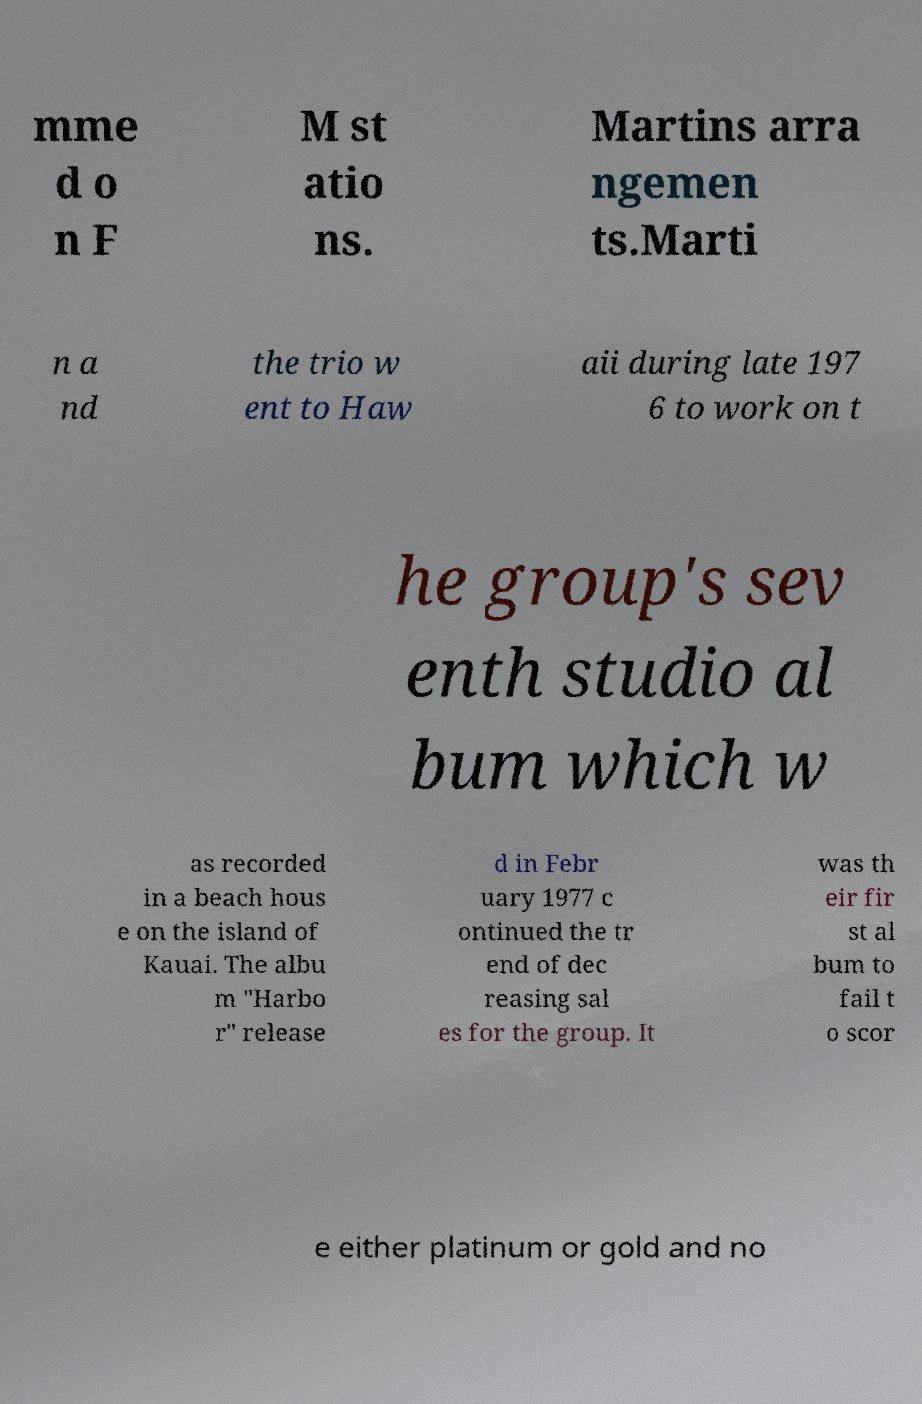For documentation purposes, I need the text within this image transcribed. Could you provide that? mme d o n F M st atio ns. Martins arra ngemen ts.Marti n a nd the trio w ent to Haw aii during late 197 6 to work on t he group's sev enth studio al bum which w as recorded in a beach hous e on the island of Kauai. The albu m "Harbo r" release d in Febr uary 1977 c ontinued the tr end of dec reasing sal es for the group. It was th eir fir st al bum to fail t o scor e either platinum or gold and no 